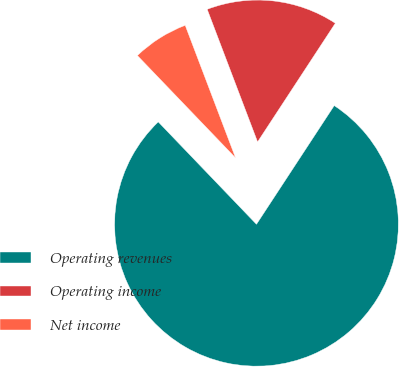Convert chart. <chart><loc_0><loc_0><loc_500><loc_500><pie_chart><fcel>Operating revenues<fcel>Operating income<fcel>Net income<nl><fcel>78.6%<fcel>15.01%<fcel>6.39%<nl></chart> 